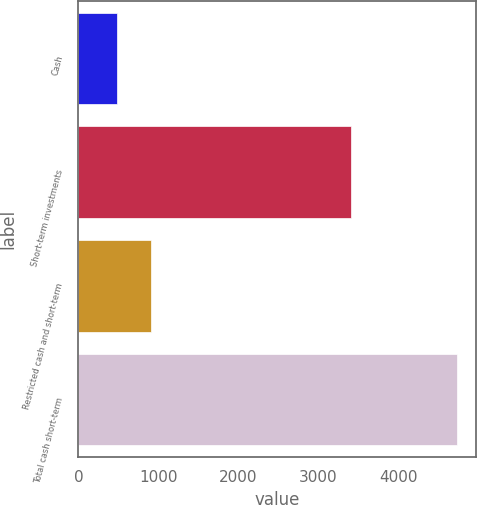<chart> <loc_0><loc_0><loc_500><loc_500><bar_chart><fcel>Cash<fcel>Short-term investments<fcel>Restricted cash and short-term<fcel>Total cash short-term<nl><fcel>480<fcel>3412<fcel>906.2<fcel>4742<nl></chart> 